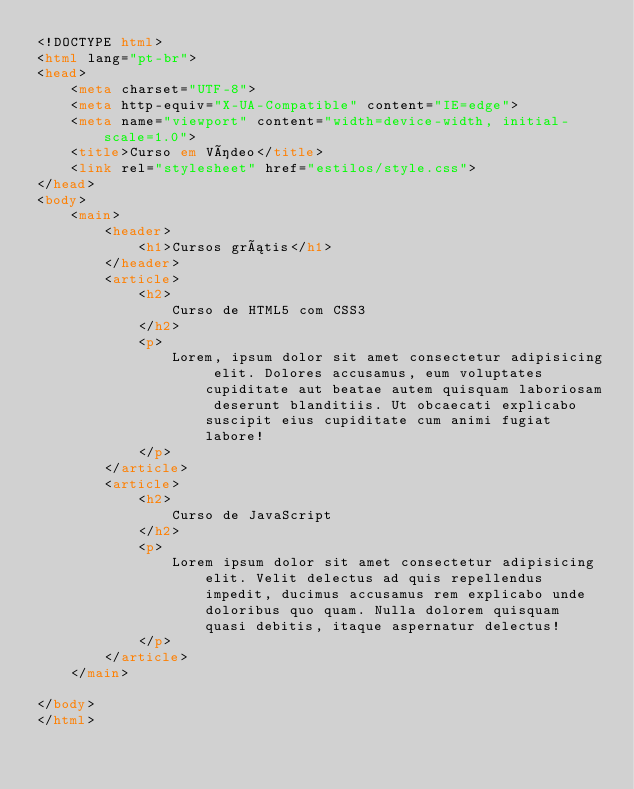Convert code to text. <code><loc_0><loc_0><loc_500><loc_500><_HTML_><!DOCTYPE html>
<html lang="pt-br">
<head>
    <meta charset="UTF-8">
    <meta http-equiv="X-UA-Compatible" content="IE=edge">
    <meta name="viewport" content="width=device-width, initial-scale=1.0">
    <title>Curso em Vídeo</title>
    <link rel="stylesheet" href="estilos/style.css">
</head>
<body>
    <main>
        <header>
            <h1>Cursos grátis</h1>
        </header>
        <article>
            <h2>
                Curso de HTML5 com CSS3
            </h2>
            <p>
                Lorem, ipsum dolor sit amet consectetur adipisicing elit. Dolores accusamus, eum voluptates cupiditate aut beatae autem quisquam laboriosam deserunt blanditiis. Ut obcaecati explicabo suscipit eius cupiditate cum animi fugiat labore!
            </p>
        </article>
        <article>
            <h2>
                Curso de JavaScript
            </h2>
            <p>
                Lorem ipsum dolor sit amet consectetur adipisicing elit. Velit delectus ad quis repellendus impedit, ducimus accusamus rem explicabo unde doloribus quo quam. Nulla dolorem quisquam quasi debitis, itaque aspernatur delectus!
            </p>
        </article>
    </main>
    
</body>
</html></code> 